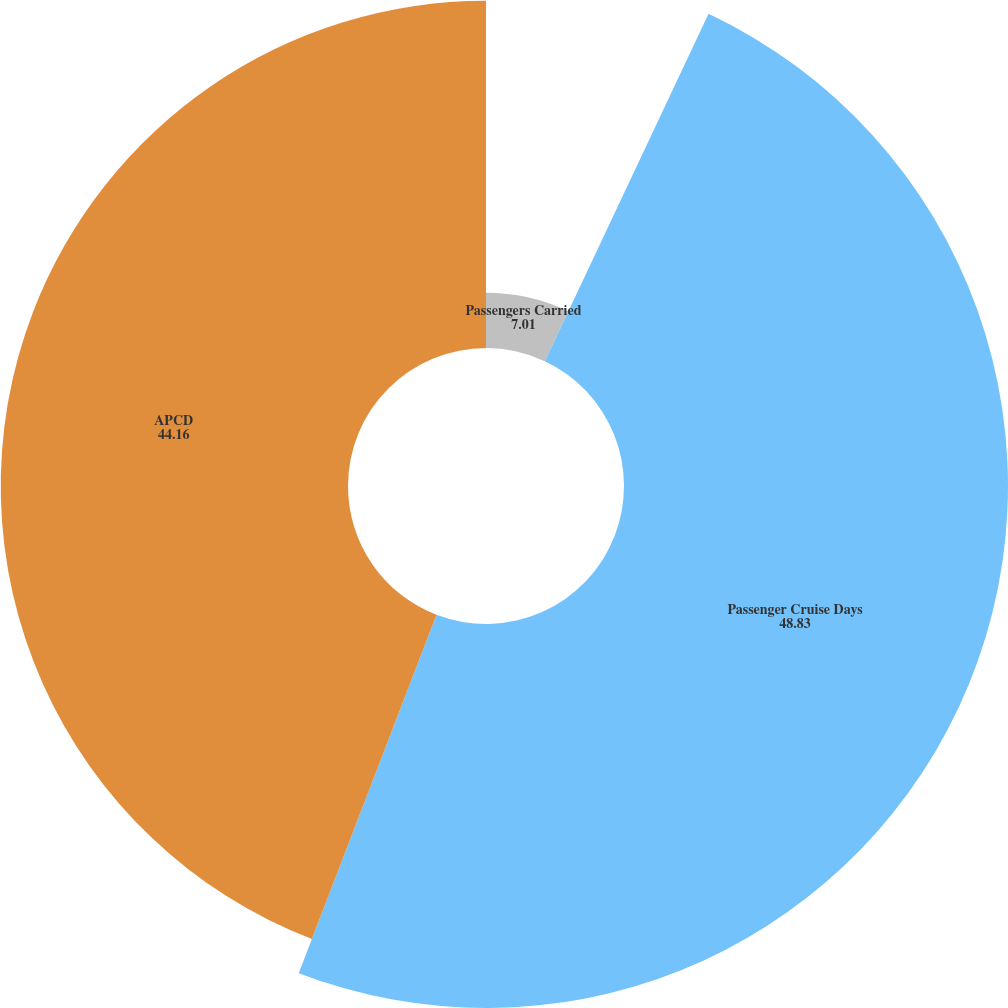<chart> <loc_0><loc_0><loc_500><loc_500><pie_chart><fcel>Passengers Carried<fcel>Passenger Cruise Days<fcel>APCD<fcel>Occupancy<nl><fcel>7.01%<fcel>48.83%<fcel>44.16%<fcel>0.0%<nl></chart> 